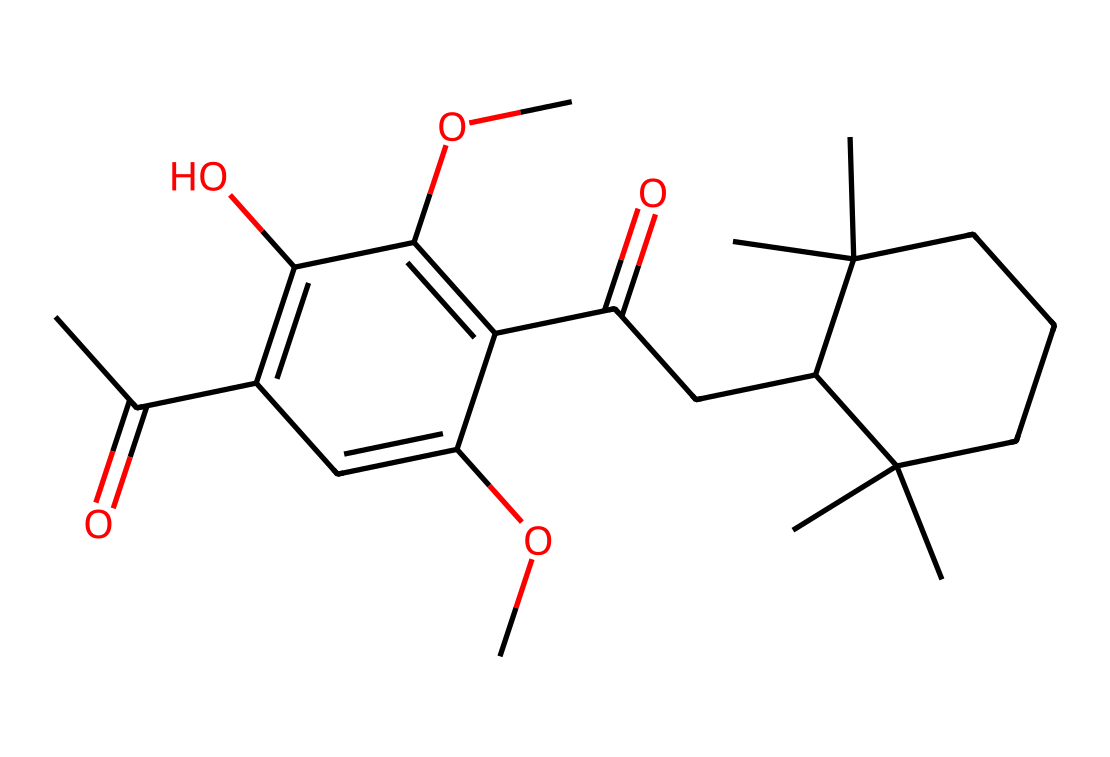How many rings are present in the chemical structure? The given SMILES indicates that there are two distinct cyclic structures in the compound, which can be identified by looking for the 'C1' and 'C2' indicators that denote the start and end of rings.
Answer: two What functional groups are indicated in the chemical structure? By analyzing the SMILES, we can identify hydroxyl groups (–OH) and ether groups (–O–) which appear as 'C(OC)' and 'C(O)' in the notation, indicating the presence of these functional groups.
Answer: hydroxyl and ether What is the molecular formula of the compound represented? To derive the molecular formula, we count the number of each type of atom in the SMILES: Carbon (C), Hydrogen (H), and Oxygen (O) which gives a complete molecular formula C23H38O5 upon thorough evaluation of the structure.
Answer: C23H38O5 Is this compound likely to be polar or nonpolar? The presence of multiple polar functional groups like hydroxyl (–OH) suggests that the compound has polar characteristics, as these groups can interact with water via hydrogen bonding.
Answer: polar What does the chemical structure suggest about its biological activity? The presence of specific functional groups, such as hydroxyl and alkyl chains, suggests potential biological activity, possibly indicating effects on neurotransmitter pathways relevant to kava's sedative and anxiolytic properties.
Answer: sedative and anxiolytic 